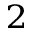Convert formula to latex. <formula><loc_0><loc_0><loc_500><loc_500>_ { 2 }</formula> 